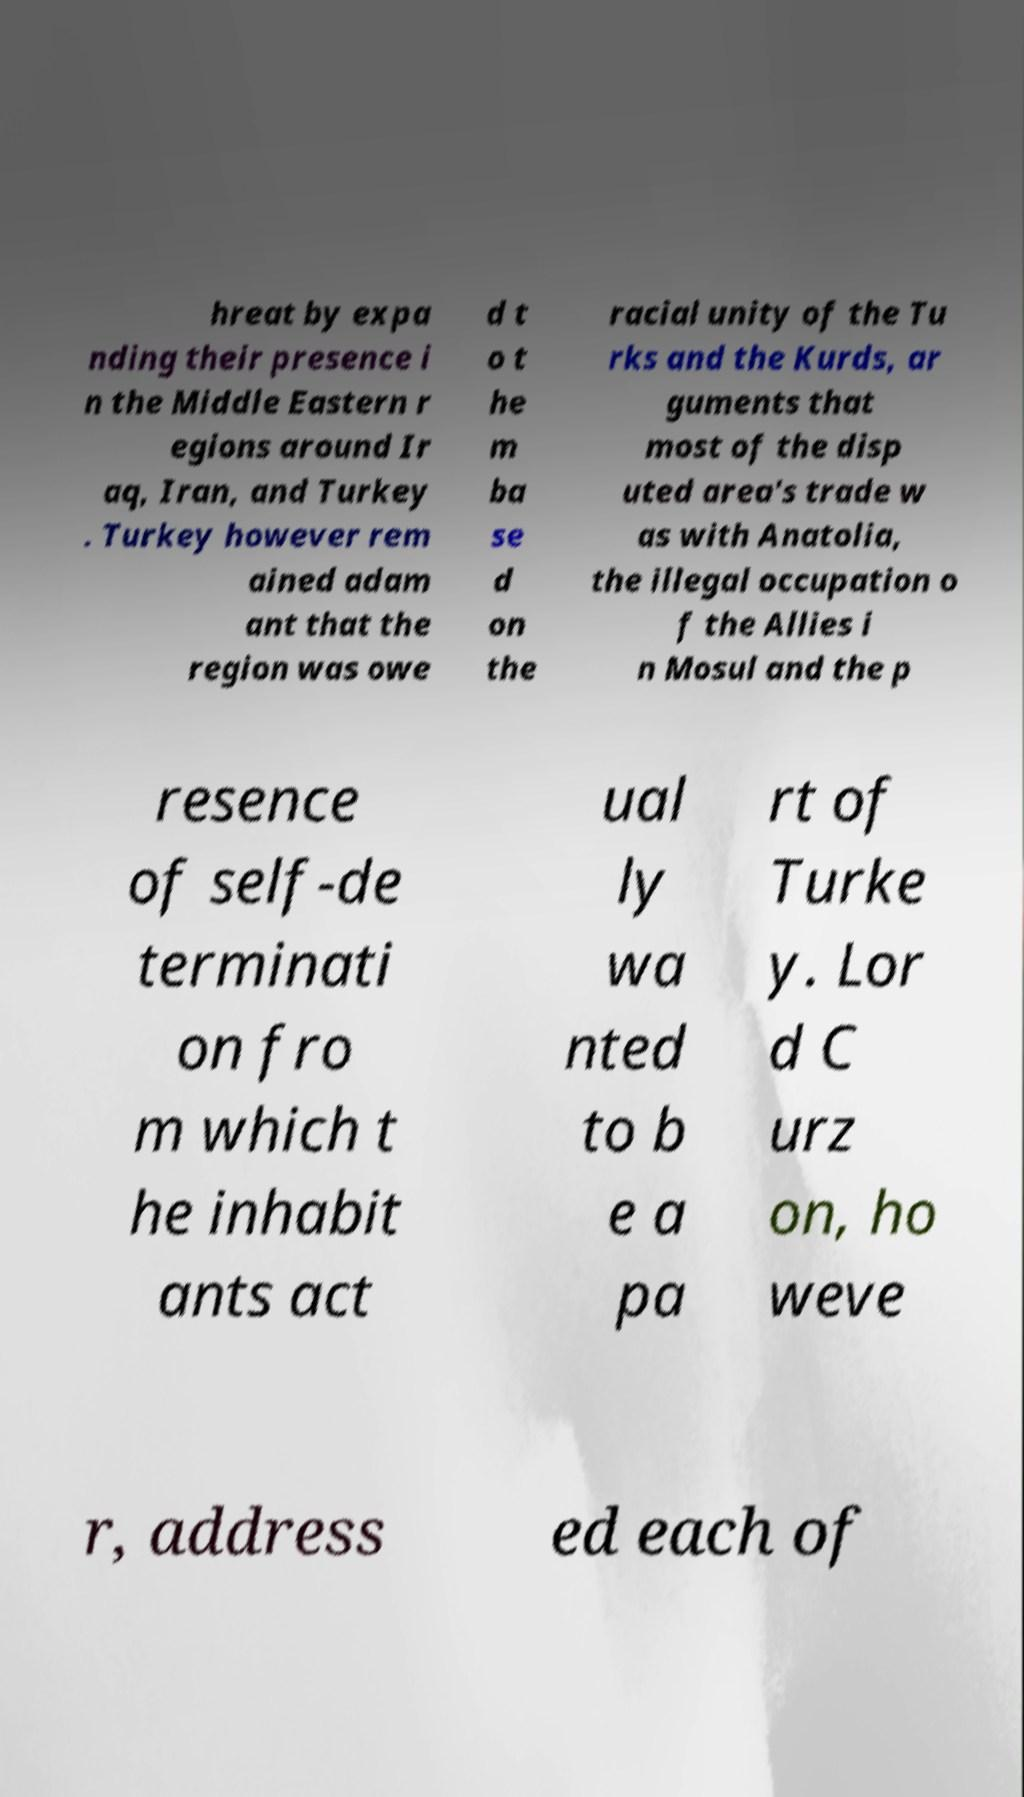For documentation purposes, I need the text within this image transcribed. Could you provide that? hreat by expa nding their presence i n the Middle Eastern r egions around Ir aq, Iran, and Turkey . Turkey however rem ained adam ant that the region was owe d t o t he m ba se d on the racial unity of the Tu rks and the Kurds, ar guments that most of the disp uted area's trade w as with Anatolia, the illegal occupation o f the Allies i n Mosul and the p resence of self-de terminati on fro m which t he inhabit ants act ual ly wa nted to b e a pa rt of Turke y. Lor d C urz on, ho weve r, address ed each of 